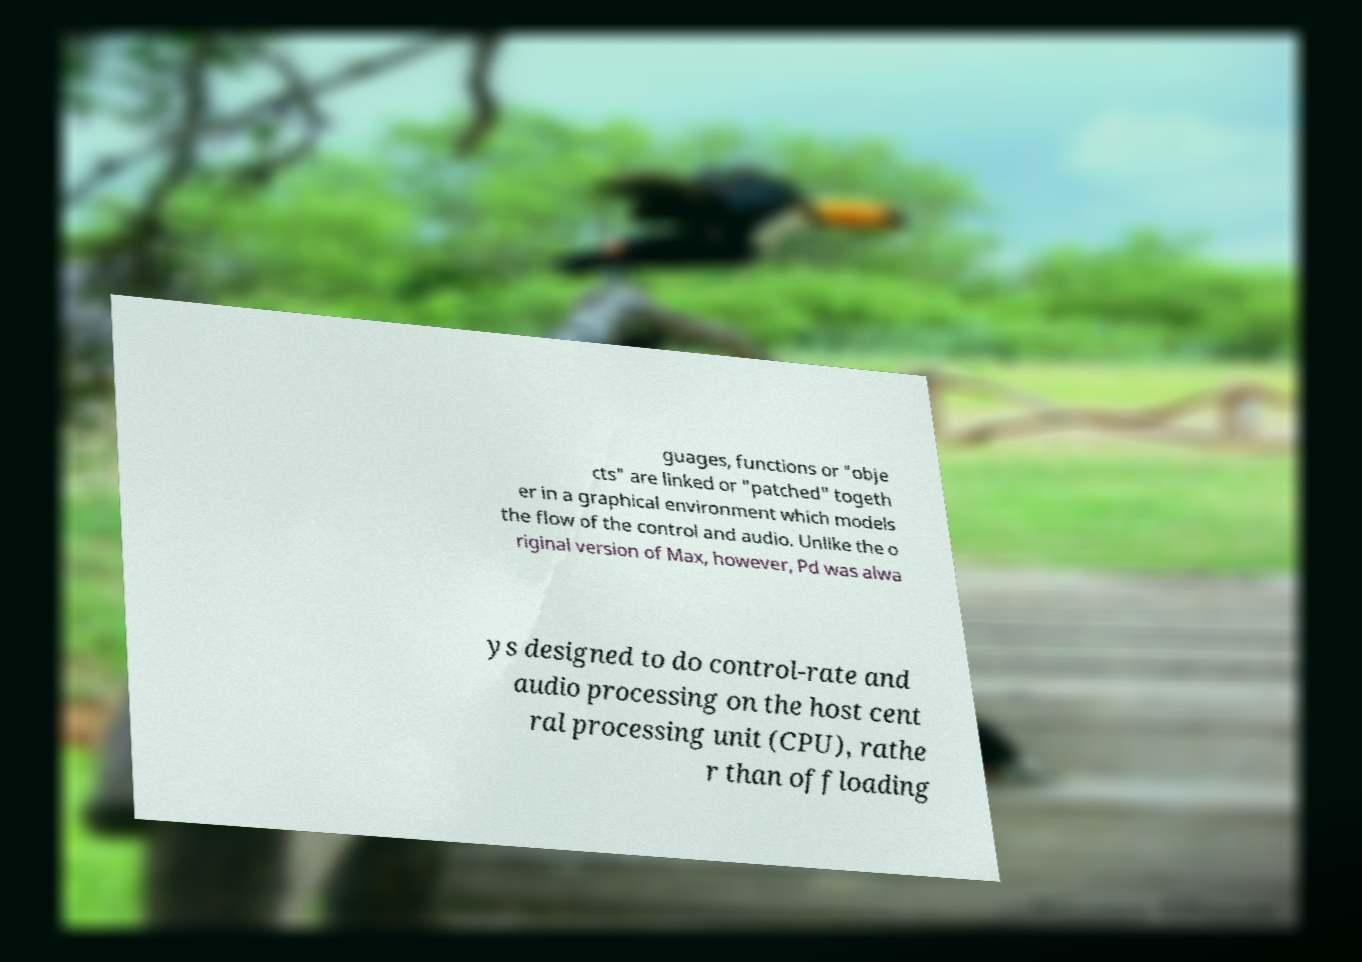For documentation purposes, I need the text within this image transcribed. Could you provide that? guages, functions or "obje cts" are linked or "patched" togeth er in a graphical environment which models the flow of the control and audio. Unlike the o riginal version of Max, however, Pd was alwa ys designed to do control-rate and audio processing on the host cent ral processing unit (CPU), rathe r than offloading 